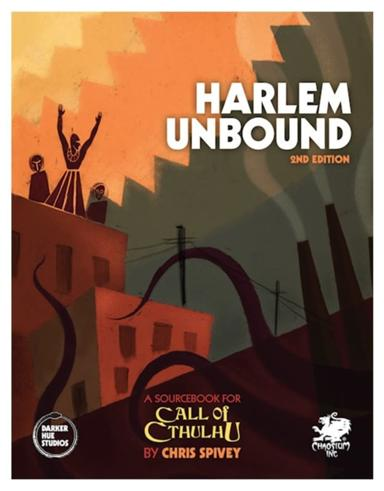What is the Call of Cthulhu role-playing game? 'Call of Cthulhu' is a popular tabletop role-playing game designed by Sandy Petersen and is based on the fictional universe of H.P. Lovecraft's writings. Players step into the shoes of detectives, scholars, and adventurers to explore mysterious cases filled with occult and mythic elements. The game is celebrated for its focus on storytelling, complex character development, and creating a palpable atmosphere of suspense and imminent danger, often leading players through a gripping narrative of discovery and survival against eldritch forces. 